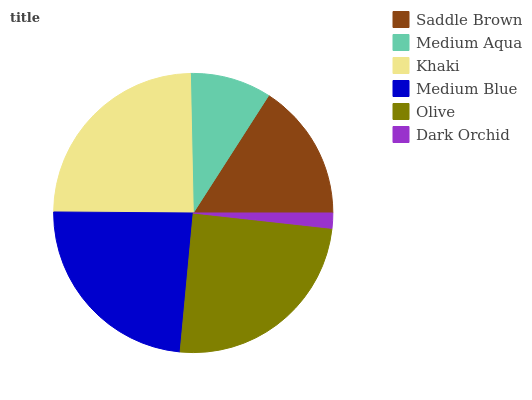Is Dark Orchid the minimum?
Answer yes or no. Yes. Is Olive the maximum?
Answer yes or no. Yes. Is Medium Aqua the minimum?
Answer yes or no. No. Is Medium Aqua the maximum?
Answer yes or no. No. Is Saddle Brown greater than Medium Aqua?
Answer yes or no. Yes. Is Medium Aqua less than Saddle Brown?
Answer yes or no. Yes. Is Medium Aqua greater than Saddle Brown?
Answer yes or no. No. Is Saddle Brown less than Medium Aqua?
Answer yes or no. No. Is Medium Blue the high median?
Answer yes or no. Yes. Is Saddle Brown the low median?
Answer yes or no. Yes. Is Khaki the high median?
Answer yes or no. No. Is Medium Blue the low median?
Answer yes or no. No. 